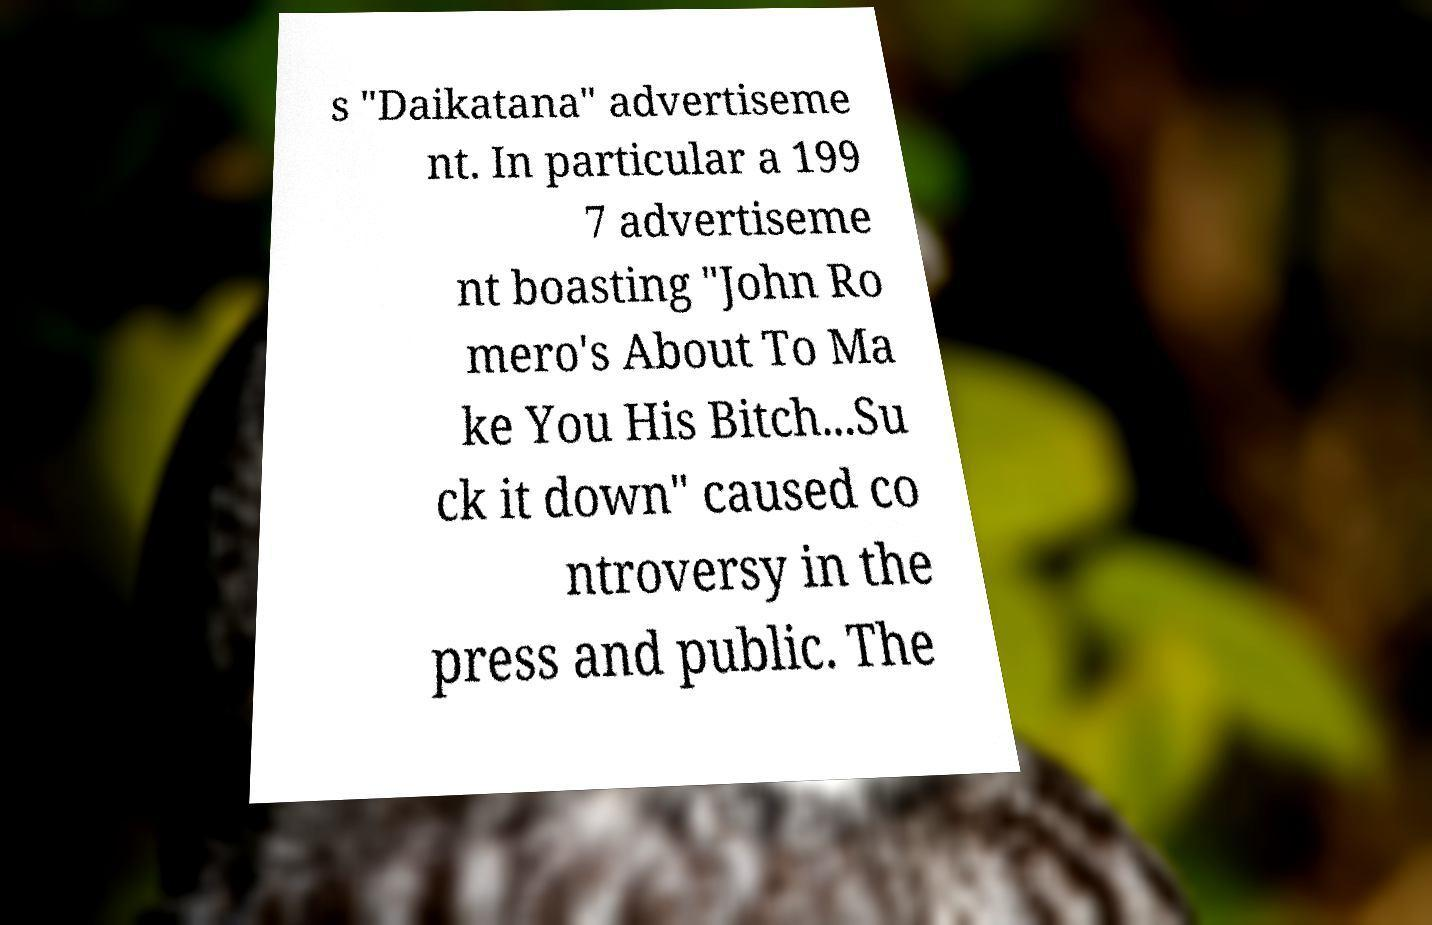For documentation purposes, I need the text within this image transcribed. Could you provide that? s "Daikatana" advertiseme nt. In particular a 199 7 advertiseme nt boasting "John Ro mero's About To Ma ke You His Bitch...Su ck it down" caused co ntroversy in the press and public. The 